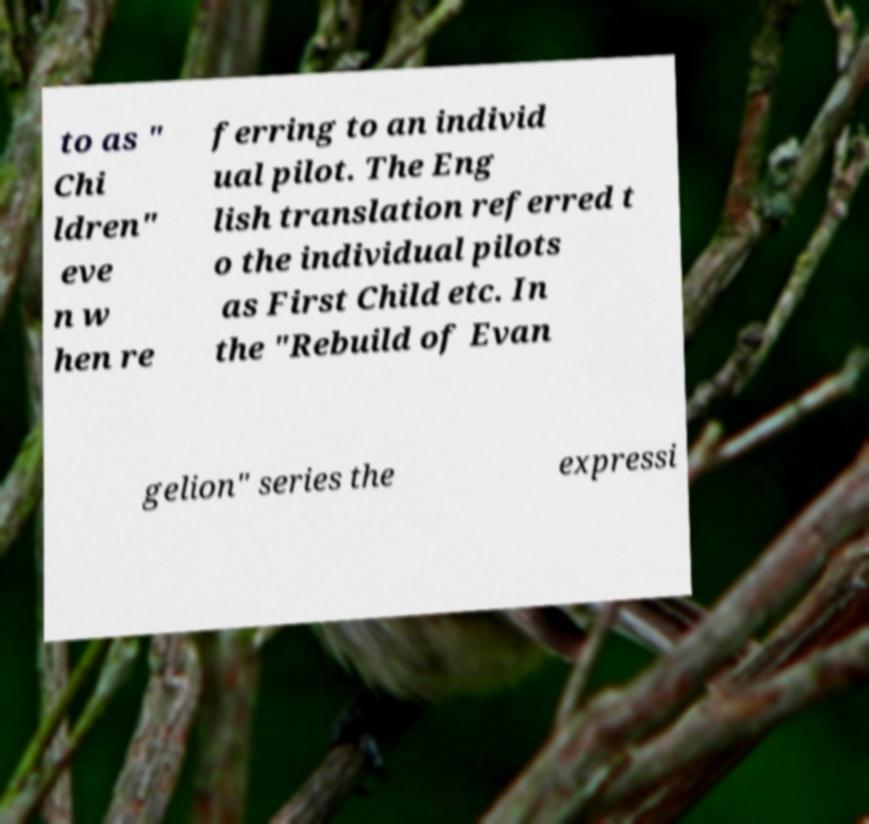I need the written content from this picture converted into text. Can you do that? to as " Chi ldren" eve n w hen re ferring to an individ ual pilot. The Eng lish translation referred t o the individual pilots as First Child etc. In the "Rebuild of Evan gelion" series the expressi 